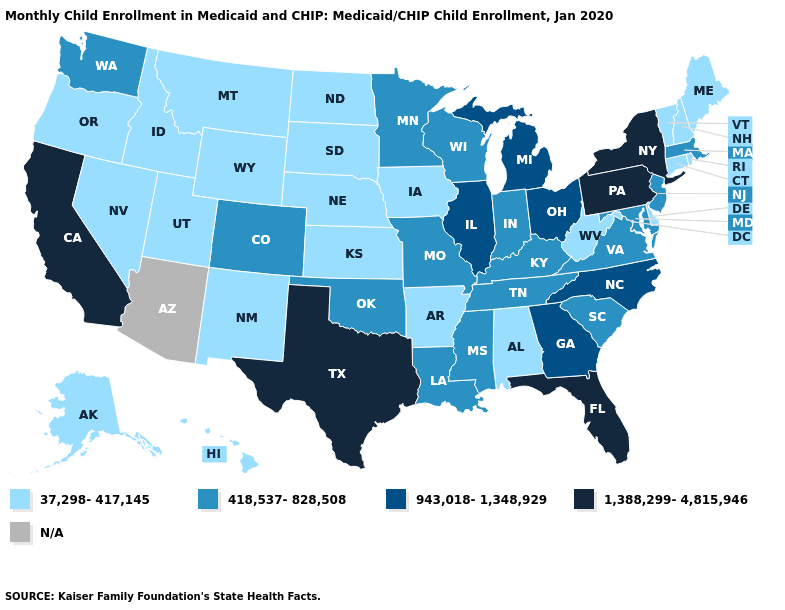Name the states that have a value in the range 943,018-1,348,929?
Keep it brief. Georgia, Illinois, Michigan, North Carolina, Ohio. What is the value of Wyoming?
Short answer required. 37,298-417,145. Which states have the highest value in the USA?
Concise answer only. California, Florida, New York, Pennsylvania, Texas. Which states have the highest value in the USA?
Be succinct. California, Florida, New York, Pennsylvania, Texas. Is the legend a continuous bar?
Keep it brief. No. Name the states that have a value in the range 418,537-828,508?
Write a very short answer. Colorado, Indiana, Kentucky, Louisiana, Maryland, Massachusetts, Minnesota, Mississippi, Missouri, New Jersey, Oklahoma, South Carolina, Tennessee, Virginia, Washington, Wisconsin. Which states have the lowest value in the USA?
Be succinct. Alabama, Alaska, Arkansas, Connecticut, Delaware, Hawaii, Idaho, Iowa, Kansas, Maine, Montana, Nebraska, Nevada, New Hampshire, New Mexico, North Dakota, Oregon, Rhode Island, South Dakota, Utah, Vermont, West Virginia, Wyoming. Name the states that have a value in the range 418,537-828,508?
Short answer required. Colorado, Indiana, Kentucky, Louisiana, Maryland, Massachusetts, Minnesota, Mississippi, Missouri, New Jersey, Oklahoma, South Carolina, Tennessee, Virginia, Washington, Wisconsin. Name the states that have a value in the range 1,388,299-4,815,946?
Be succinct. California, Florida, New York, Pennsylvania, Texas. What is the value of Indiana?
Short answer required. 418,537-828,508. What is the value of Oklahoma?
Give a very brief answer. 418,537-828,508. What is the value of Alabama?
Short answer required. 37,298-417,145. What is the highest value in states that border Arizona?
Keep it brief. 1,388,299-4,815,946. Among the states that border Idaho , does Nevada have the highest value?
Short answer required. No. What is the value of West Virginia?
Keep it brief. 37,298-417,145. 